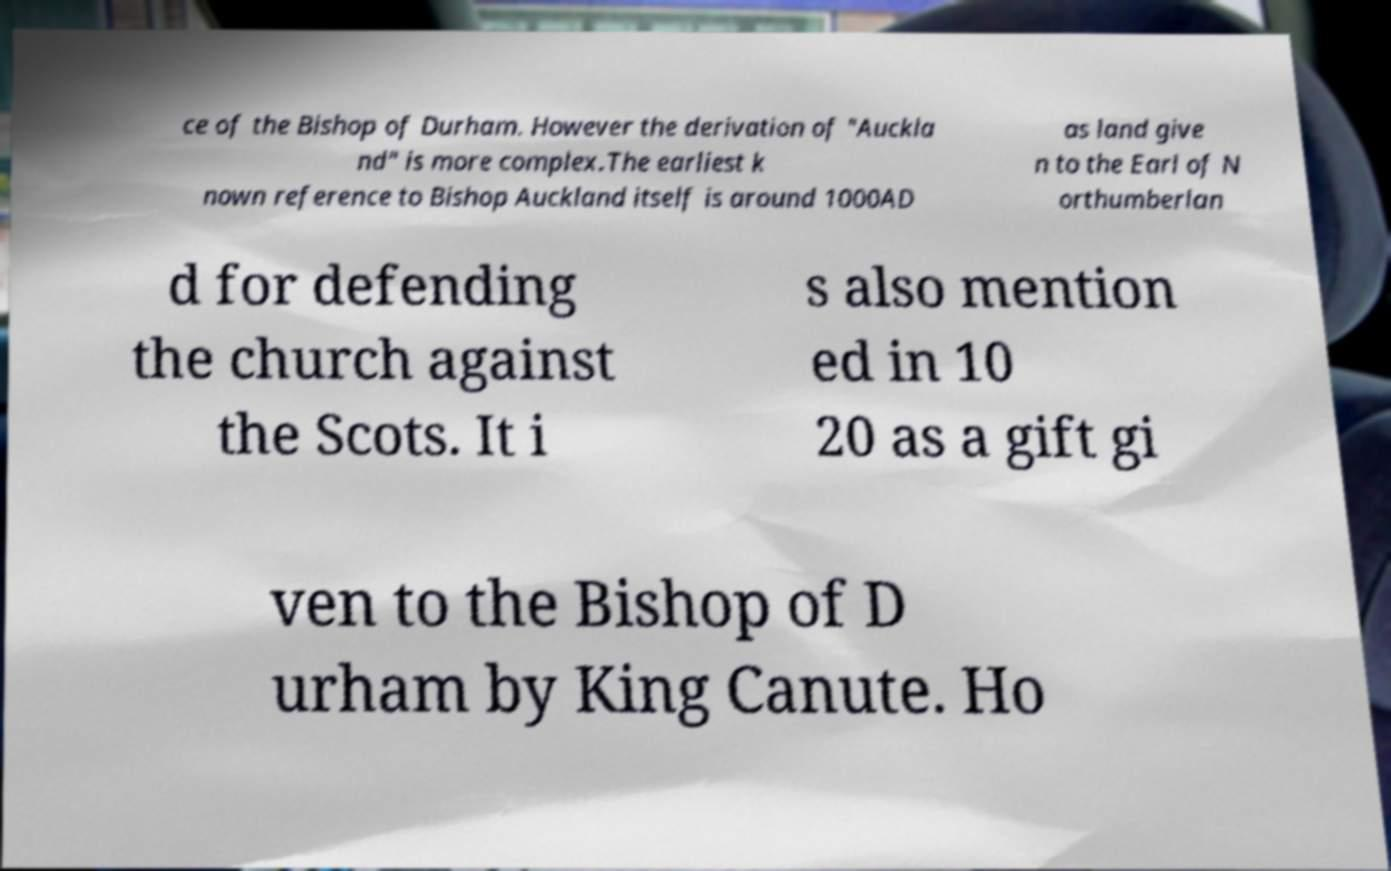I need the written content from this picture converted into text. Can you do that? ce of the Bishop of Durham. However the derivation of "Auckla nd" is more complex.The earliest k nown reference to Bishop Auckland itself is around 1000AD as land give n to the Earl of N orthumberlan d for defending the church against the Scots. It i s also mention ed in 10 20 as a gift gi ven to the Bishop of D urham by King Canute. Ho 